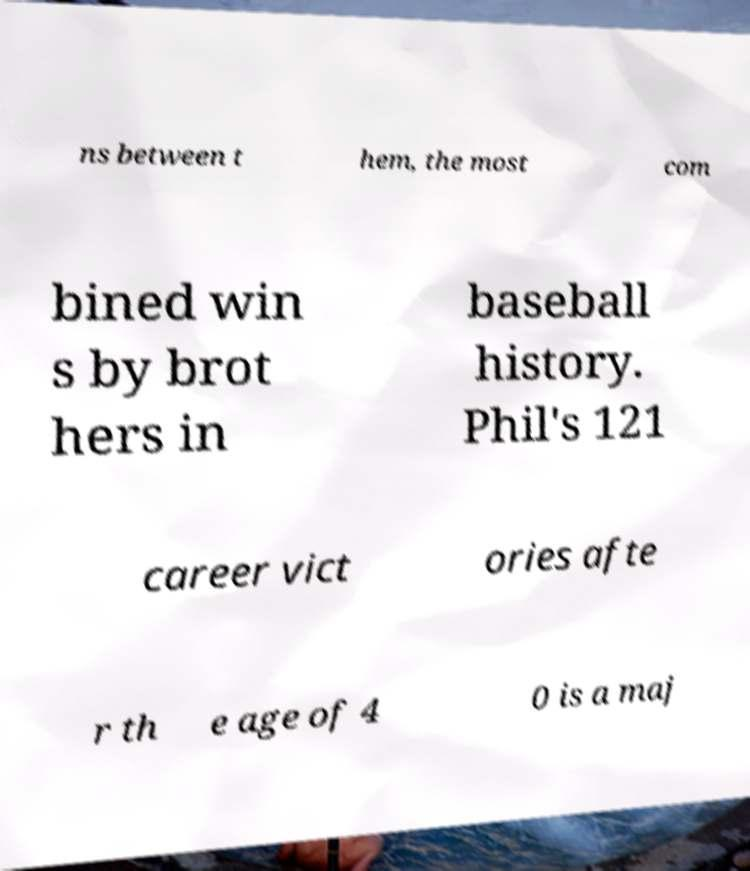Please identify and transcribe the text found in this image. ns between t hem, the most com bined win s by brot hers in baseball history. Phil's 121 career vict ories afte r th e age of 4 0 is a maj 